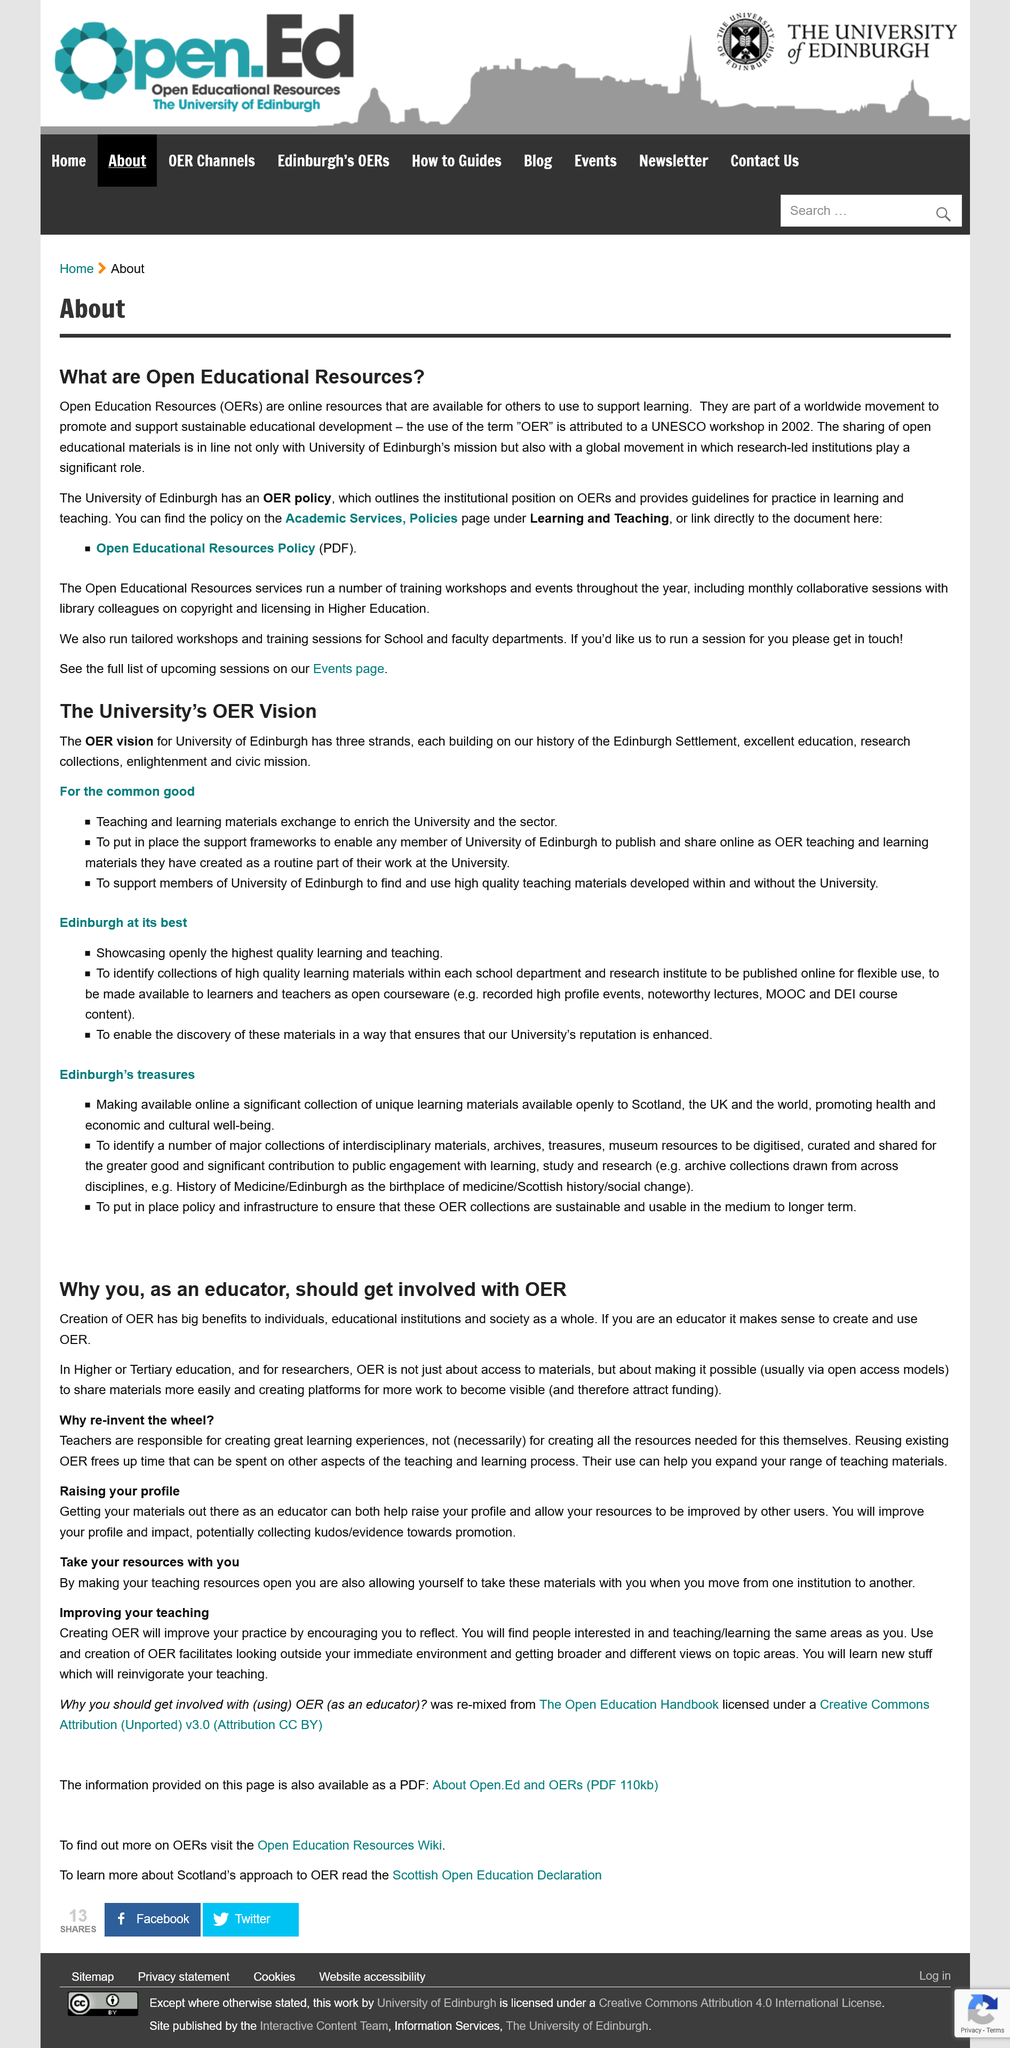Identify some key points in this picture. Creating OER improves one's practice by encouraging reflection. The University's reputation is of utmost importance to the team, and they aim to enhance it through their work. Exchanging teaching and learning materials is a crucial aspect of the OER Vision. The University of Edinburgh has an OER Policy that states the institution's stance on OERs and provides guidelines for their use in learning and teaching. According to the University's OER Vision, three strands are mentioned. 